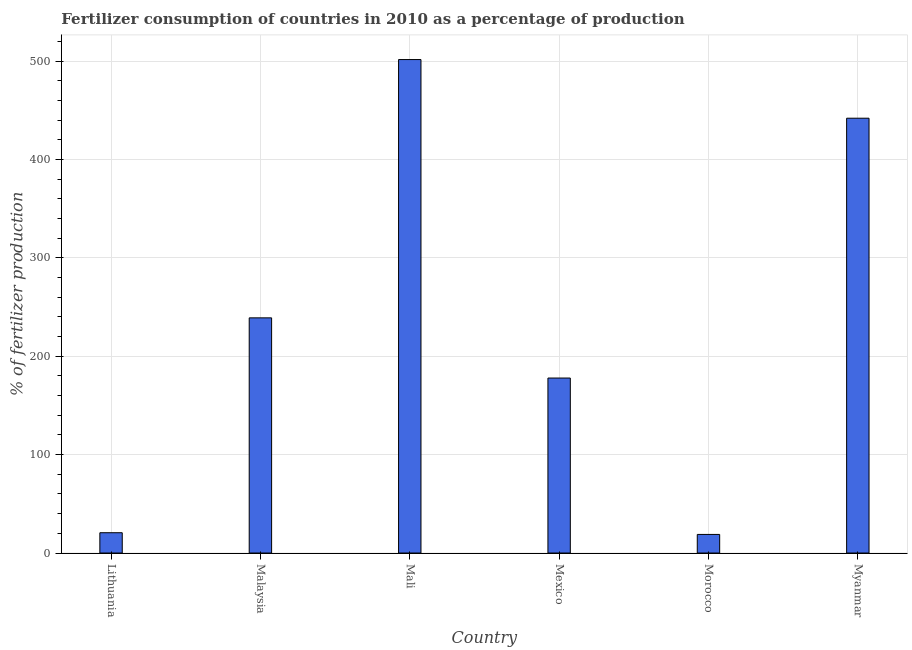Does the graph contain grids?
Give a very brief answer. Yes. What is the title of the graph?
Keep it short and to the point. Fertilizer consumption of countries in 2010 as a percentage of production. What is the label or title of the Y-axis?
Your answer should be compact. % of fertilizer production. What is the amount of fertilizer consumption in Morocco?
Provide a succinct answer. 18.9. Across all countries, what is the maximum amount of fertilizer consumption?
Offer a very short reply. 501.61. Across all countries, what is the minimum amount of fertilizer consumption?
Make the answer very short. 18.9. In which country was the amount of fertilizer consumption maximum?
Give a very brief answer. Mali. In which country was the amount of fertilizer consumption minimum?
Your answer should be compact. Morocco. What is the sum of the amount of fertilizer consumption?
Provide a short and direct response. 1400.02. What is the difference between the amount of fertilizer consumption in Lithuania and Malaysia?
Provide a short and direct response. -218.42. What is the average amount of fertilizer consumption per country?
Make the answer very short. 233.34. What is the median amount of fertilizer consumption?
Your answer should be very brief. 208.46. In how many countries, is the amount of fertilizer consumption greater than 280 %?
Your answer should be very brief. 2. What is the ratio of the amount of fertilizer consumption in Malaysia to that in Myanmar?
Give a very brief answer. 0.54. Is the amount of fertilizer consumption in Mali less than that in Morocco?
Offer a very short reply. No. What is the difference between the highest and the second highest amount of fertilizer consumption?
Offer a very short reply. 59.63. What is the difference between the highest and the lowest amount of fertilizer consumption?
Your answer should be very brief. 482.71. In how many countries, is the amount of fertilizer consumption greater than the average amount of fertilizer consumption taken over all countries?
Give a very brief answer. 3. How many bars are there?
Make the answer very short. 6. What is the difference between two consecutive major ticks on the Y-axis?
Offer a very short reply. 100. Are the values on the major ticks of Y-axis written in scientific E-notation?
Your answer should be very brief. No. What is the % of fertilizer production in Lithuania?
Offer a terse response. 20.63. What is the % of fertilizer production in Malaysia?
Offer a terse response. 239.04. What is the % of fertilizer production in Mali?
Your answer should be very brief. 501.61. What is the % of fertilizer production in Mexico?
Your answer should be very brief. 177.87. What is the % of fertilizer production of Morocco?
Provide a succinct answer. 18.9. What is the % of fertilizer production in Myanmar?
Your answer should be very brief. 441.98. What is the difference between the % of fertilizer production in Lithuania and Malaysia?
Give a very brief answer. -218.42. What is the difference between the % of fertilizer production in Lithuania and Mali?
Offer a terse response. -480.98. What is the difference between the % of fertilizer production in Lithuania and Mexico?
Provide a succinct answer. -157.25. What is the difference between the % of fertilizer production in Lithuania and Morocco?
Offer a very short reply. 1.73. What is the difference between the % of fertilizer production in Lithuania and Myanmar?
Keep it short and to the point. -421.35. What is the difference between the % of fertilizer production in Malaysia and Mali?
Make the answer very short. -262.56. What is the difference between the % of fertilizer production in Malaysia and Mexico?
Offer a terse response. 61.17. What is the difference between the % of fertilizer production in Malaysia and Morocco?
Your response must be concise. 220.15. What is the difference between the % of fertilizer production in Malaysia and Myanmar?
Your answer should be very brief. -202.93. What is the difference between the % of fertilizer production in Mali and Mexico?
Offer a terse response. 323.73. What is the difference between the % of fertilizer production in Mali and Morocco?
Give a very brief answer. 482.71. What is the difference between the % of fertilizer production in Mali and Myanmar?
Your response must be concise. 59.63. What is the difference between the % of fertilizer production in Mexico and Morocco?
Your response must be concise. 158.98. What is the difference between the % of fertilizer production in Mexico and Myanmar?
Keep it short and to the point. -264.1. What is the difference between the % of fertilizer production in Morocco and Myanmar?
Keep it short and to the point. -423.08. What is the ratio of the % of fertilizer production in Lithuania to that in Malaysia?
Offer a very short reply. 0.09. What is the ratio of the % of fertilizer production in Lithuania to that in Mali?
Your answer should be very brief. 0.04. What is the ratio of the % of fertilizer production in Lithuania to that in Mexico?
Provide a succinct answer. 0.12. What is the ratio of the % of fertilizer production in Lithuania to that in Morocco?
Your answer should be compact. 1.09. What is the ratio of the % of fertilizer production in Lithuania to that in Myanmar?
Provide a short and direct response. 0.05. What is the ratio of the % of fertilizer production in Malaysia to that in Mali?
Keep it short and to the point. 0.48. What is the ratio of the % of fertilizer production in Malaysia to that in Mexico?
Your answer should be very brief. 1.34. What is the ratio of the % of fertilizer production in Malaysia to that in Morocco?
Keep it short and to the point. 12.65. What is the ratio of the % of fertilizer production in Malaysia to that in Myanmar?
Provide a succinct answer. 0.54. What is the ratio of the % of fertilizer production in Mali to that in Mexico?
Give a very brief answer. 2.82. What is the ratio of the % of fertilizer production in Mali to that in Morocco?
Provide a short and direct response. 26.55. What is the ratio of the % of fertilizer production in Mali to that in Myanmar?
Your answer should be very brief. 1.14. What is the ratio of the % of fertilizer production in Mexico to that in Morocco?
Your answer should be very brief. 9.41. What is the ratio of the % of fertilizer production in Mexico to that in Myanmar?
Your answer should be compact. 0.4. What is the ratio of the % of fertilizer production in Morocco to that in Myanmar?
Keep it short and to the point. 0.04. 